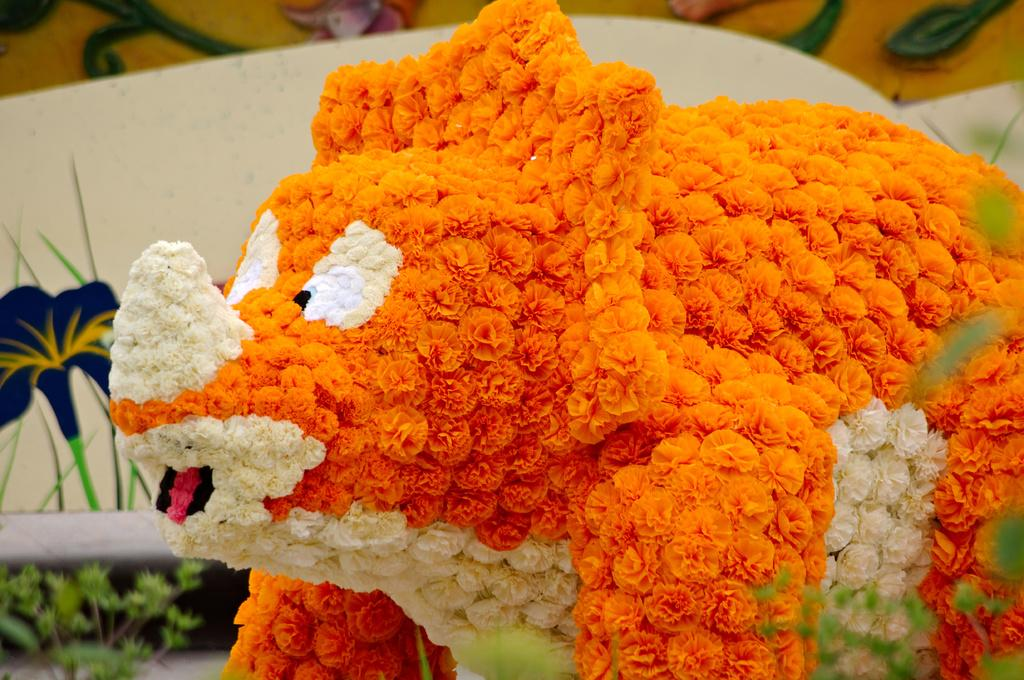What object is present in the image that can hold food? There is a plate in the image. What is placed on top of the plate? There is a bunch of colorful flowers on top of the plate. Where is the ghost in the image? There is no ghost present in the image. What type of laborer can be seen working in the image? There is no laborer present in the image. 